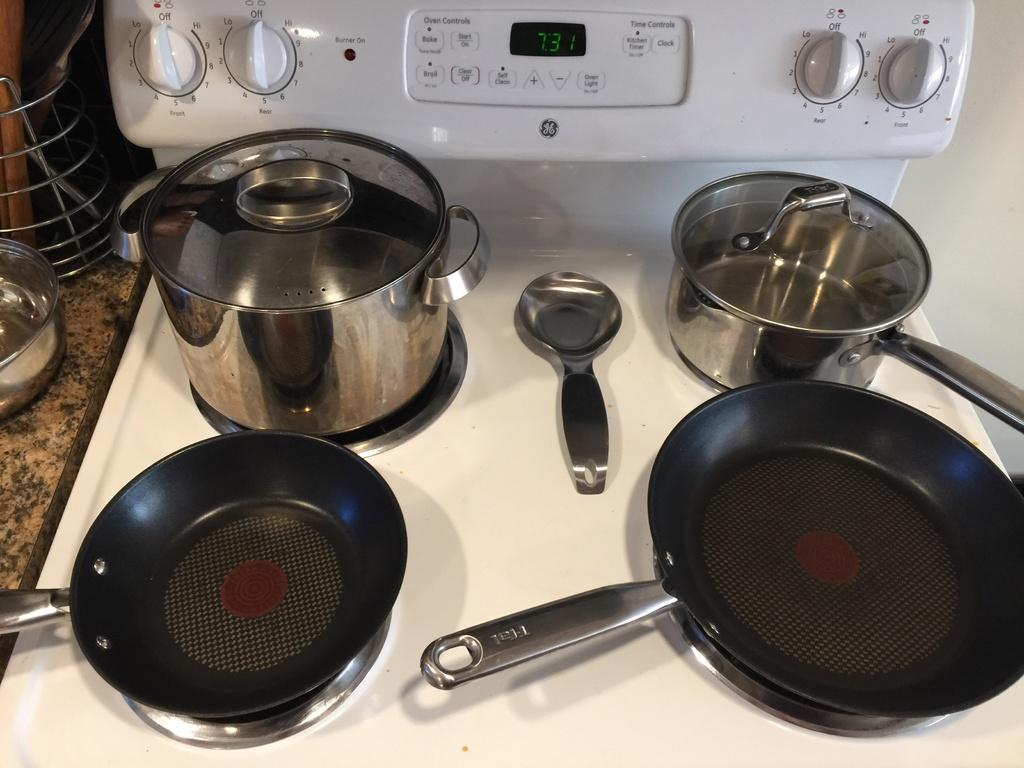<image>
Share a concise interpretation of the image provided. A GE brand stovetop with pots and pans on the stove 